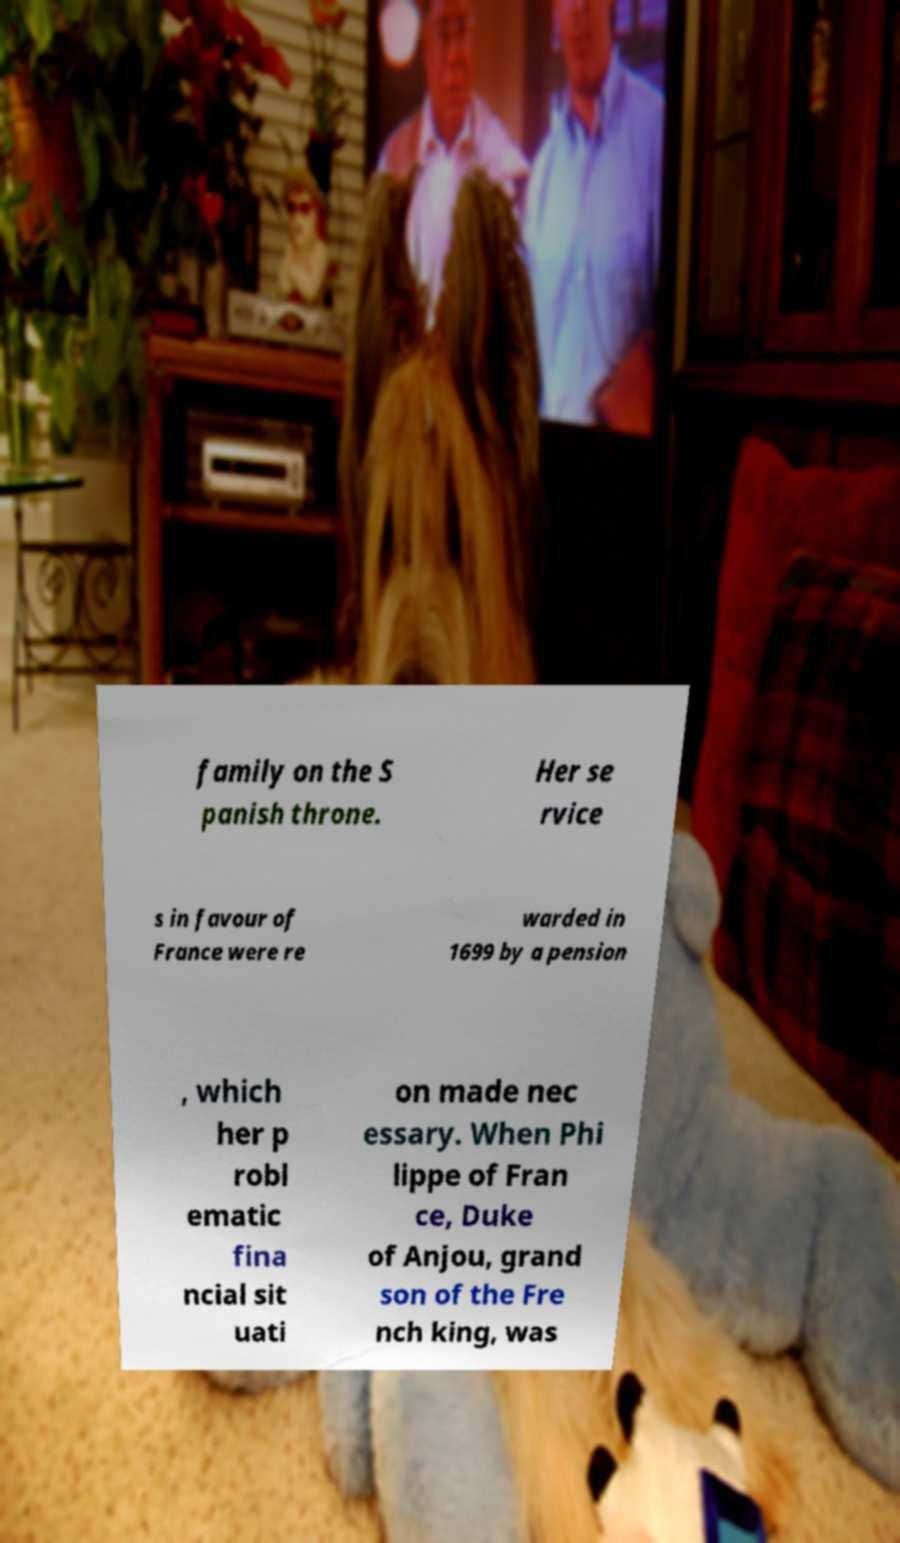Can you read and provide the text displayed in the image?This photo seems to have some interesting text. Can you extract and type it out for me? family on the S panish throne. Her se rvice s in favour of France were re warded in 1699 by a pension , which her p robl ematic fina ncial sit uati on made nec essary. When Phi lippe of Fran ce, Duke of Anjou, grand son of the Fre nch king, was 